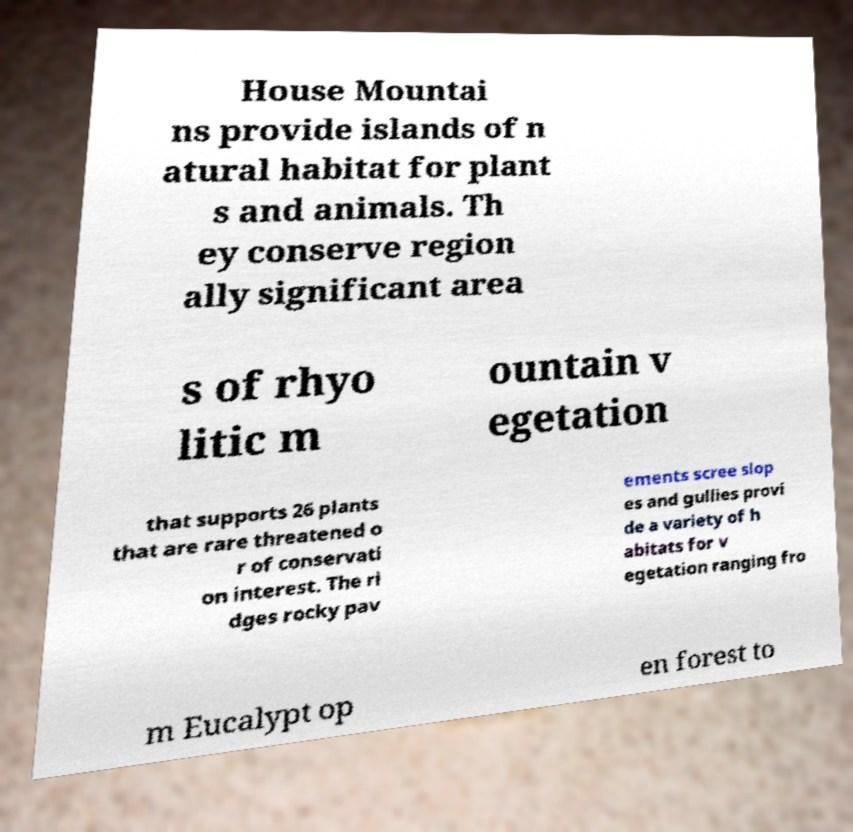Can you accurately transcribe the text from the provided image for me? House Mountai ns provide islands of n atural habitat for plant s and animals. Th ey conserve region ally significant area s of rhyo litic m ountain v egetation that supports 26 plants that are rare threatened o r of conservati on interest. The ri dges rocky pav ements scree slop es and gullies provi de a variety of h abitats for v egetation ranging fro m Eucalypt op en forest to 